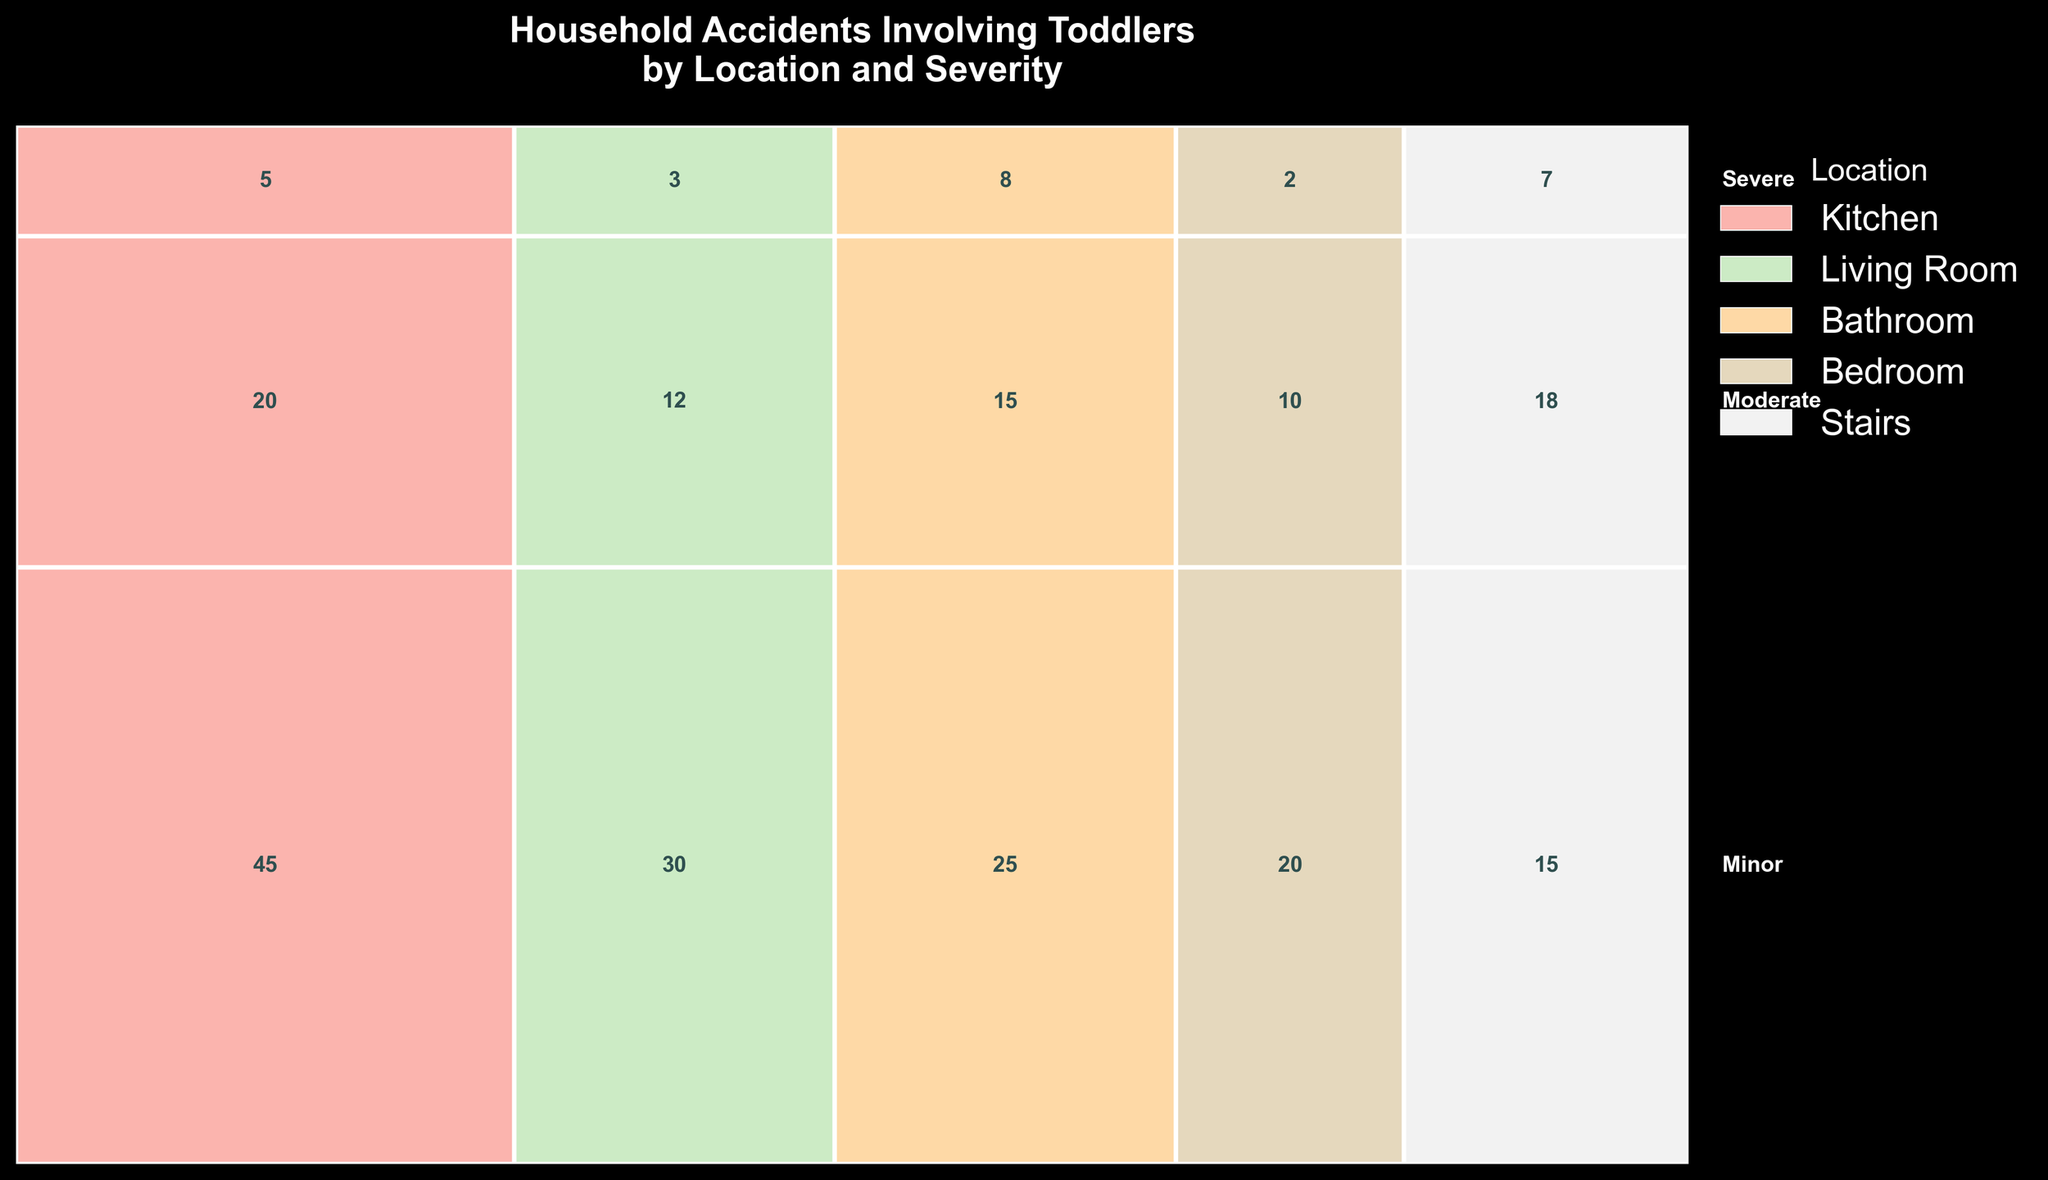How many severe accidents happened in the kitchen? Look at the figure and find the part labeled 'Severe' in the section corresponding to the kitchen's color. Read the number inside the rectangle.
Answer: 5 Which location has the highest number of minor accidents? Identify rectangles labeled 'Minor' and then compare the numbers in each location's segment. The one with the highest number will be clear from the plot.
Answer: Kitchen What's the total number of accidents that occurred in the bathroom? Sum the numbers within the bathroom section for minor, moderate, and severe accidents. (25 + 15 + 8)
Answer: 48 Compare the number of severe accidents in the bathroom and the living room. Which one has more? Focus on the 'Severe' labels for both the bathroom and the living room. Compare their values directly.
Answer: Bathroom What is the color representing accidents happening on the stairs? Look at the legend that associates colors with locations. Identify the color next to 'Stairs'.
Answer: (Varies based on figure) In which location did the highest number of moderate accidents occur? Check the 'Moderate' sections for each location and identify the number associated with each. The highest number can then be determined.
Answer: Stairs Which severity level has the lowest number of accidents in total? Sum the numbers across all locations for each severity level and compare totals. Identify the severity with the smallest total.
Answer: Severe How many more minor accidents occurred in the kitchen than in the living room? Subtract the number of minor accidents in the living room from those in the kitchen. Calculate (45 - 30).
Answer: 15 Are there more moderate accidents in the kitchen or the bathroom? Compare the 'Moderate' sections for both kitchen and bathroom. Read the numbers and compare.
Answer: Kitchen 